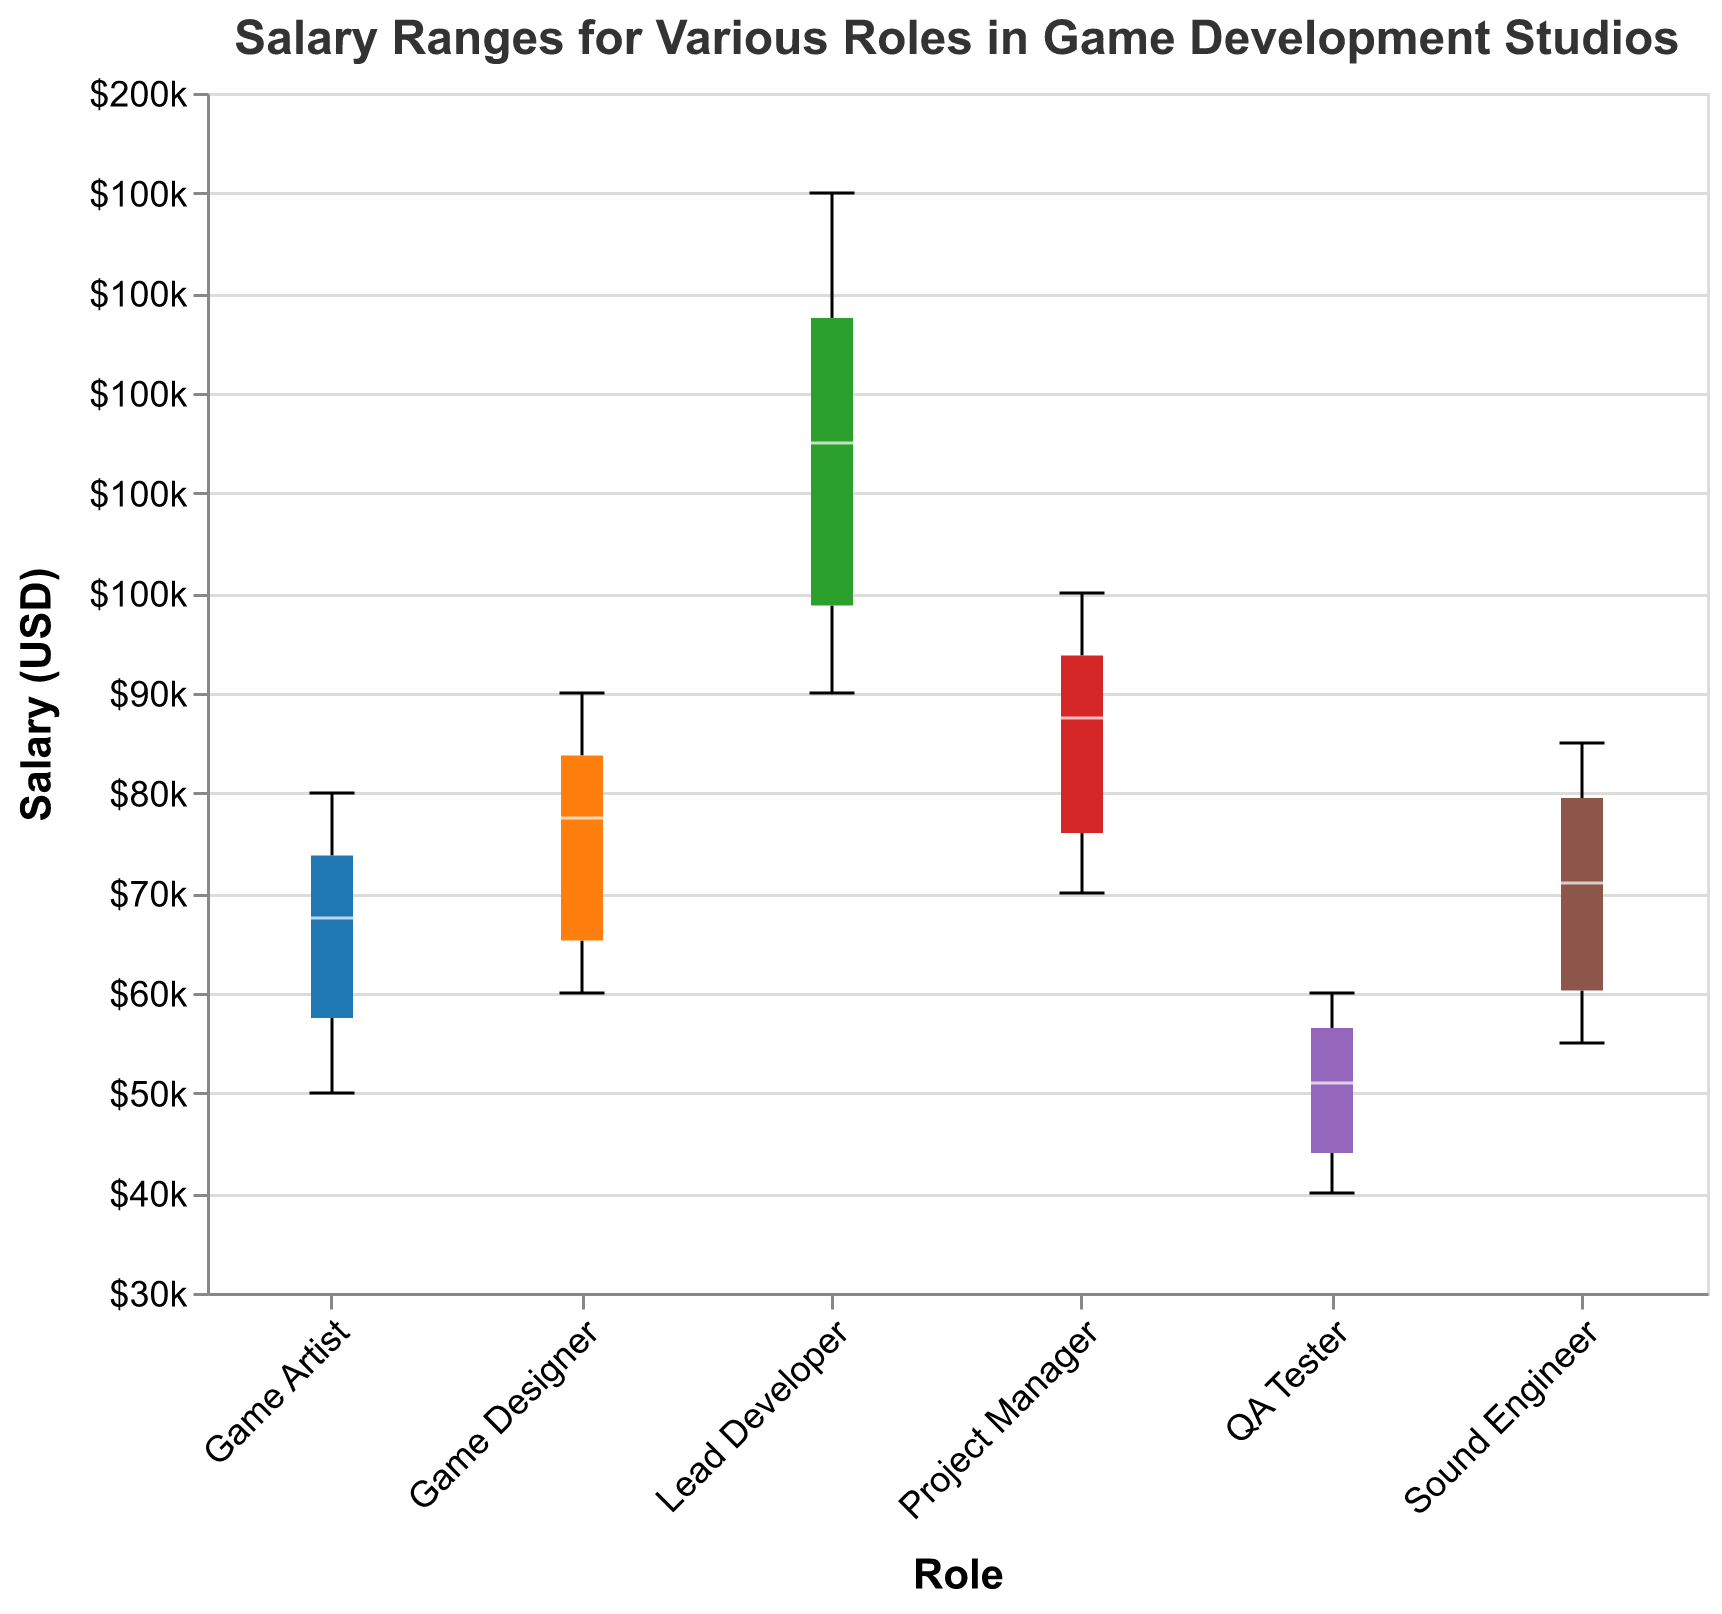What is the title of the figure? The title is displayed at the top of the figure and clearly states what the plot represents.
Answer: Salary Ranges for Various Roles in Game Development Studios What is the range of salaries covered in the plot? The y-axis defines the range of salaries, which are from $30,000 to $150,000.
Answer: $30,000 to $150,000 Which role has the highest median salary? To find the role with the highest median salary, observe the white median lines inside the notches of each boxplot. The Lead Developer role has the highest median salary.
Answer: Lead Developer What is the approximate median salary for a QA Tester? Locate the median line (white) for the QA Tester role. It appears to be around $50,000.
Answer: $50,000 Which role shows the greatest range in salary values? The role with the longest boxplot whiskers (extent of minimum to maximum) indicates the greatest range. The Lead Developer role shows the largest range.
Answer: Lead Developer Are salaries for Entry level in the Game Designer role higher or lower compared to Entry level in the QA Tester role? Compare the boxplots for Game Designer Entry level and QA Tester Entry level. Game Designer Entry level salaries are higher.
Answer: Higher What is the interquartile range (IQR) for the Sound Engineer role? The IQR is represented by the length of the box (from Q1 to Q3). For Sound Engineer, it is approximately between $55,000 to $82,000.
Answer: $27,000 How do the salary quartiles for Mid-level Game Artists compare to Mid-level Game Designers? Compare the boxes for the two roles at Mid-level. The middle half of salaries for Mid-level Game Artists ranges between $65,000 and $70,000, whereas for Game Designers it's between $75,000 and $80,000. Game Designers have slightly higher quartiles.
Answer: Game Designers have higher quartiles Is there any overlap in the salary ranges between Senior Sound Engineers and Senior Game Artists? The notches of the boxplots for these roles will indicate overlap in the median range if they intersect. For Senior Sound Engineers and Senior Game Artists, the ranges do overlap somewhat.
Answer: Yes For which experience level is the salary variability (spread) widest in the Lead Developer role? Check the spread of the salaries for Entry, Mid, and Senior levels within the Lead Developer role. Senior level shows the widest spread.
Answer: Senior 